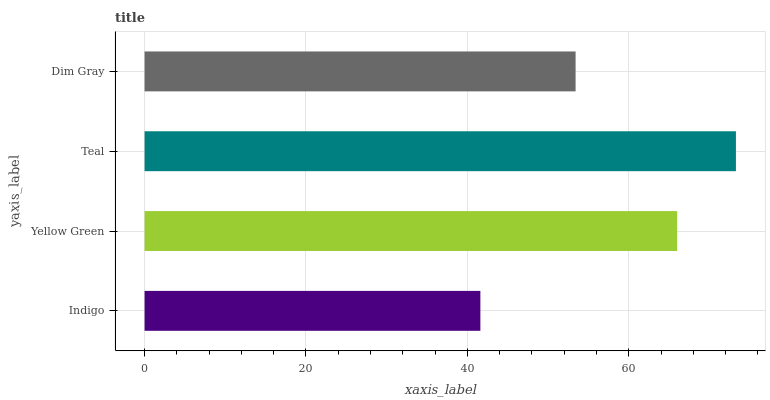Is Indigo the minimum?
Answer yes or no. Yes. Is Teal the maximum?
Answer yes or no. Yes. Is Yellow Green the minimum?
Answer yes or no. No. Is Yellow Green the maximum?
Answer yes or no. No. Is Yellow Green greater than Indigo?
Answer yes or no. Yes. Is Indigo less than Yellow Green?
Answer yes or no. Yes. Is Indigo greater than Yellow Green?
Answer yes or no. No. Is Yellow Green less than Indigo?
Answer yes or no. No. Is Yellow Green the high median?
Answer yes or no. Yes. Is Dim Gray the low median?
Answer yes or no. Yes. Is Dim Gray the high median?
Answer yes or no. No. Is Yellow Green the low median?
Answer yes or no. No. 